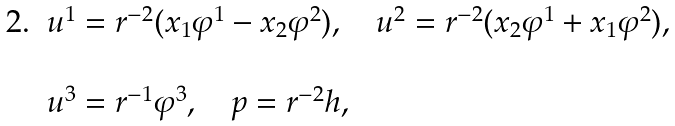<formula> <loc_0><loc_0><loc_500><loc_500>\, \begin{array} { l l } 2 . & u ^ { 1 } = r ^ { - 2 } ( x _ { 1 } \varphi ^ { 1 } - x _ { 2 } \varphi ^ { 2 } ) , \quad u ^ { 2 } = r ^ { - 2 } ( x _ { 2 } \varphi ^ { 1 } + x _ { 1 } \varphi ^ { 2 } ) , \\ \\ & u ^ { 3 } = r ^ { - 1 } \varphi ^ { 3 } , \quad p = r ^ { - 2 } h , \end{array}</formula> 